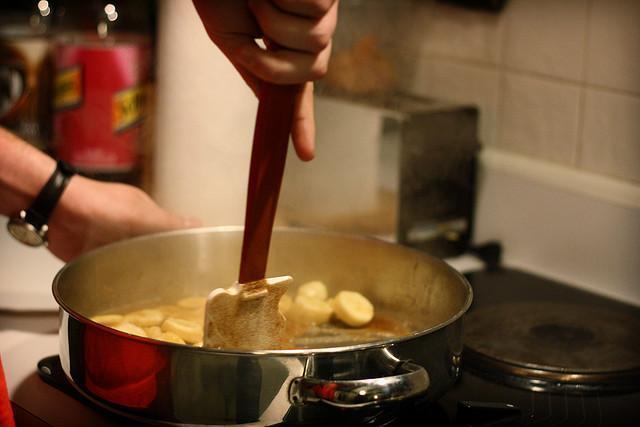What action is the person doing?
Indicate the correct response by choosing from the four available options to answer the question.
Options: Stirring, eating, kneading, chopping. Stirring. 